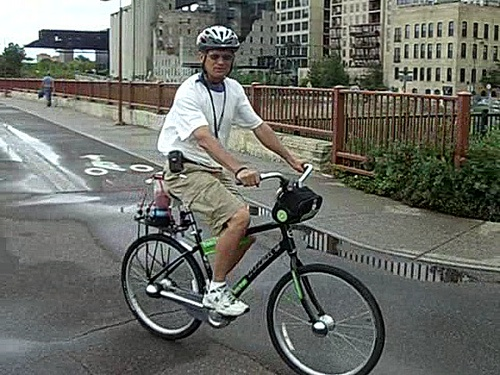Describe the objects in this image and their specific colors. I can see bicycle in white, gray, black, and darkgray tones, people in white, darkgray, gray, and black tones, and people in white, gray, black, and darkgray tones in this image. 